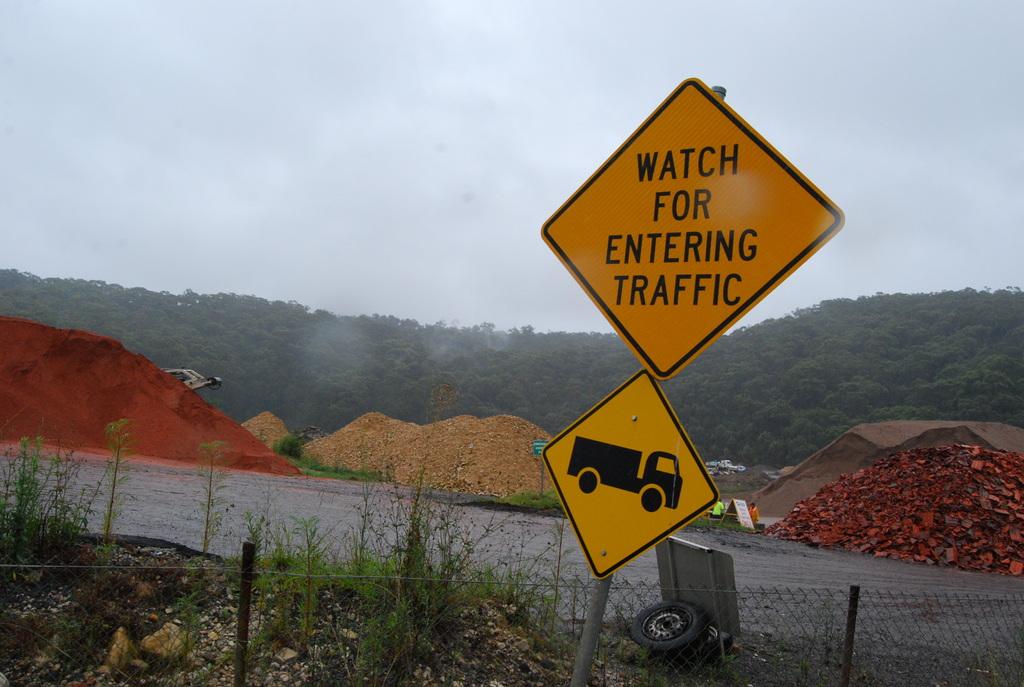What does the sign warn of?
Ensure brevity in your answer.  Entering traffic. 